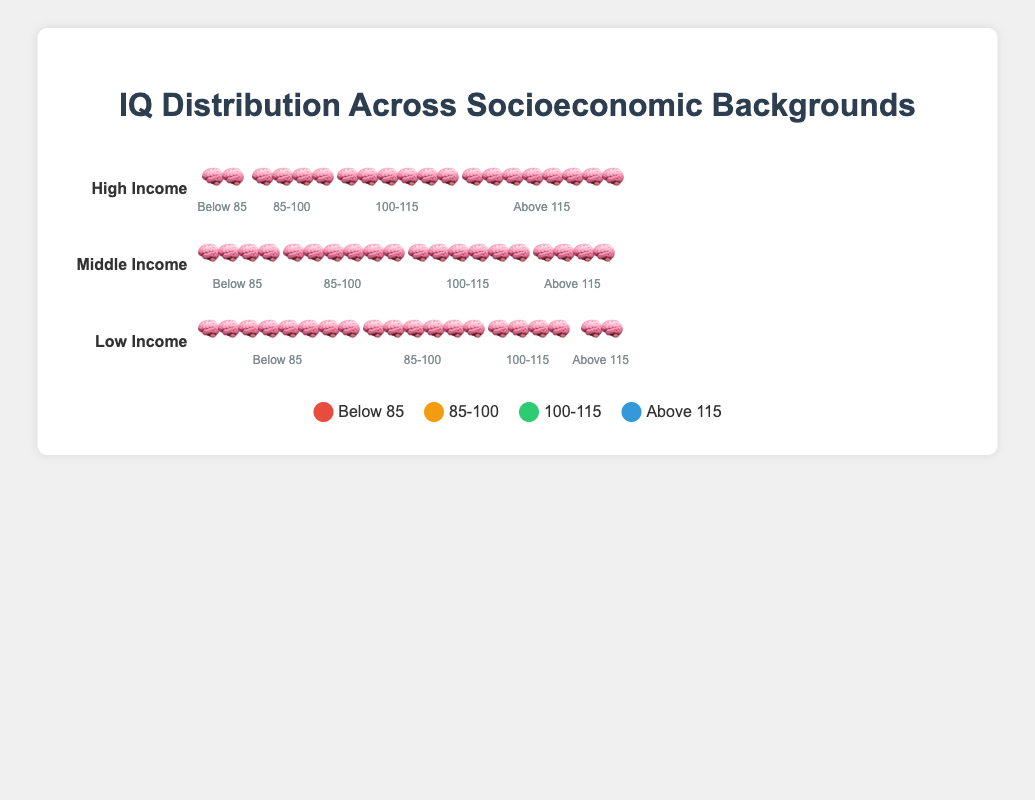What is the title of the plot? The title of the plot is located at the top center of the figure, displayed in a larger and bold font. It provides a brief description of what the plot represents.
Answer: IQ Distribution Across Socioeconomic Backgrounds Which socioeconomic group has the highest percentage of individuals with IQs above 115? To determine this, look at the "Above 115" column in each socioeconomic group. The High Income group has the most brain symbols (8 🧠), indicating the highest percentage.
Answer: High Income In which IQ range do Low Income individuals have the largest representation? Look at the Low Income group and compare the number of brain symbols in each IQ range. The "Below 85" range has the most symbols (8 🧠), indicating the largest representation.
Answer: Below 85 How many total brain symbols are displayed for the Middle Income group? Add up the brain symbols from all IQ ranges for the Middle Income group: 4 ("Below 85") + 6 ("85-100") + 6 ("100-115") + 4 ("Above 115") = 20
Answer: 20 How does the distribution of IQ scores for High Income compare to Low Income? Compare the number of brain symbols in each IQ range:
- "Below 85": High Income (2), Low Income (8)
- "85-100": High Income (4), Low Income (6)
- "100-115": High Income (6), Low Income (4)
- "Above 115": High Income (8), Low Income (2)
High Income has fewer symbols in lower IQ ranges and more in higher IQ ranges compared to Low Income.
Answer: High Income has fewer in lower ranges, more in higher ranges Which IQ range for Middle Income and High Income groups has the same number of brain symbols? Compare the brain symbols in each IQ range between the two groups. Both have 6 symbols in the "100-115" range.
Answer: 100-115 What percentage of High Income individuals are in the "Below 85" IQ range in proportion to the total brain symbols for High Income? High Income has 20 total symbols (2 + 4 + 6 + 8). In the "Below 85" range, there are 2 symbols. The percentage is (2/20) * 100 = 10%.
Answer: 10% Which socioeconomic group has the highest concentration of individuals in the "85-100" IQ range? Observe the number of brain symbols in the "85-100" range for each group. Low Income has 6, Middle Income has 6, and High Income has 4. Both Low and Middle Income have the highest concentration.
Answer: Low and Middle Income How does the distribution of symbols for the "100-115" IQ range differ between the three groups? Compare the "100-115" range across the groups:
- Low Income: 4 symbols
- Middle Income: 6 symbols
- High Income: 6 symbols
Middle and High Income have the same number, which is higher than Low Income.
Answer: Middle Income and High Income have more than Low Income How many more brain symbols are there for the "Above 115" range in High Income compared to Low Income? In the "Above 115" range, High Income has 8 symbols, and Low Income has 2 symbols. The difference is 8 - 2 = 6.
Answer: 6 symbols 